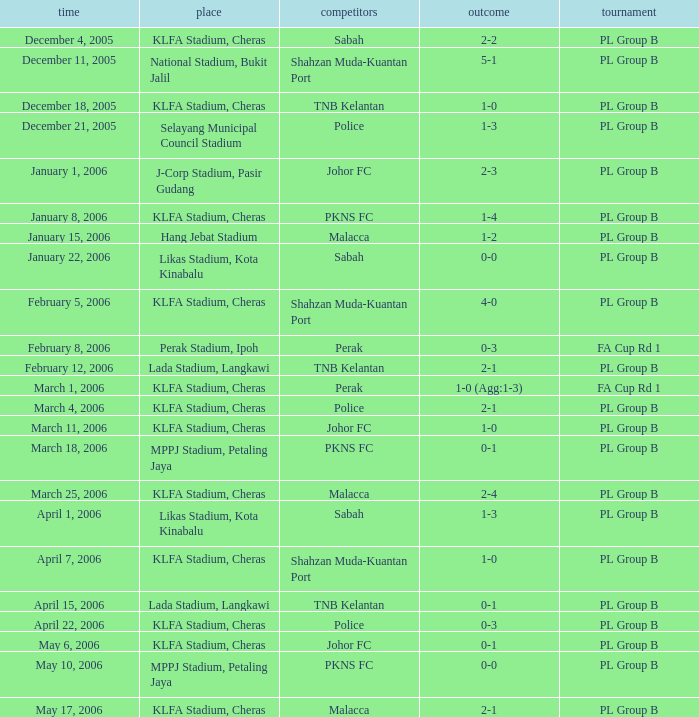Who competed on may 6, 2006? Johor FC. 